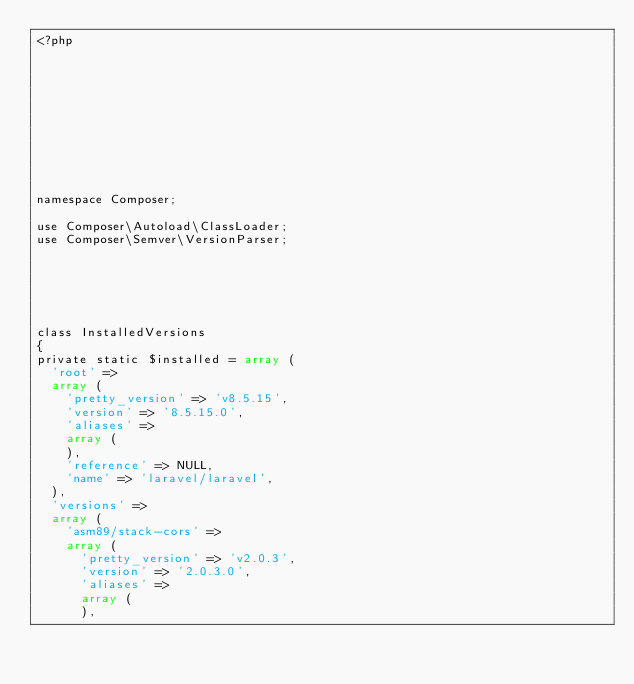<code> <loc_0><loc_0><loc_500><loc_500><_PHP_><?php











namespace Composer;

use Composer\Autoload\ClassLoader;
use Composer\Semver\VersionParser;






class InstalledVersions
{
private static $installed = array (
  'root' => 
  array (
    'pretty_version' => 'v8.5.15',
    'version' => '8.5.15.0',
    'aliases' => 
    array (
    ),
    'reference' => NULL,
    'name' => 'laravel/laravel',
  ),
  'versions' => 
  array (
    'asm89/stack-cors' => 
    array (
      'pretty_version' => 'v2.0.3',
      'version' => '2.0.3.0',
      'aliases' => 
      array (
      ),</code> 